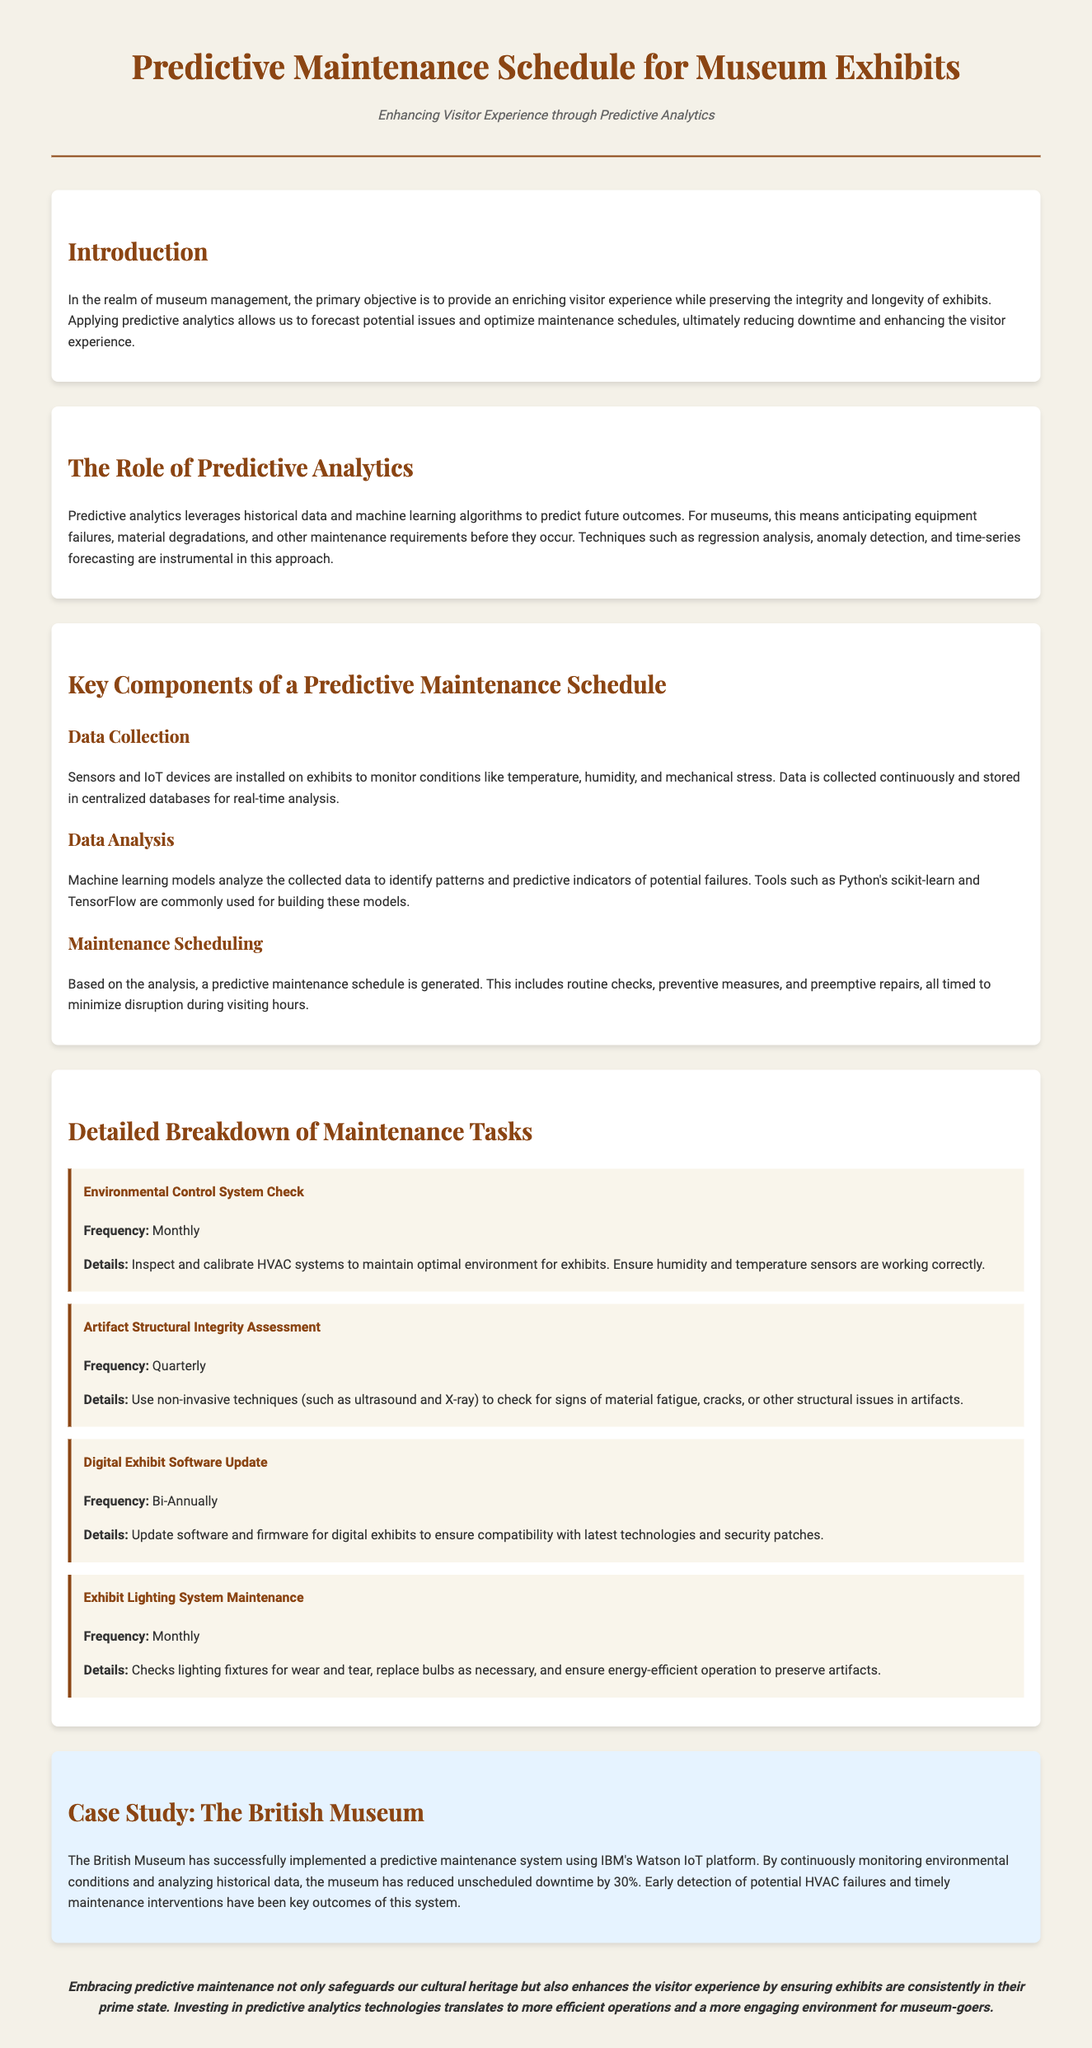What is the main objective of applying predictive analytics in museums? The main objective is to provide an enriching visitor experience while preserving the integrity and longevity of exhibits.
Answer: Enriching visitor experience What does the Environmental Control System Check inspect? The Environmental Control System Check inspects and calibrates HVAC systems to maintain optimal environment for exhibits.
Answer: HVAC systems How often is the Artifact Structural Integrity Assessment conducted? The frequency of the Artifact Structural Integrity Assessment is mentioned in the document as quarterly.
Answer: Quarterly What technology did The British Museum use for their predictive maintenance system? The technology used by The British Museum is IBM's Watson IoT platform.
Answer: IBM's Watson IoT What maintenance task is conducted bi-annually? The maintenance task conducted bi-annually is the Digital Exhibit Software Update.
Answer: Digital Exhibit Software Update What is a key benefit highlighted in the case study about predictive maintenance? A key benefit highlighted is that unscheduled downtime has been reduced by 30%.
Answer: 30% reduction Which machine learning tools are mentioned for building predictive models? The tools mentioned for building predictive models are Python's scikit-learn and TensorFlow.
Answer: scikit-learn and TensorFlow Why is it important to replace bulbs in the Exhibit Lighting System Maintenance? It's important to replace bulbs to ensure energy-efficient operation to preserve artifacts.
Answer: Energy-efficient operation What does a predictive maintenance schedule include? A predictive maintenance schedule includes routine checks, preventive measures, and preemptive repairs.
Answer: Routine checks, preventive measures, and preemptive repairs 